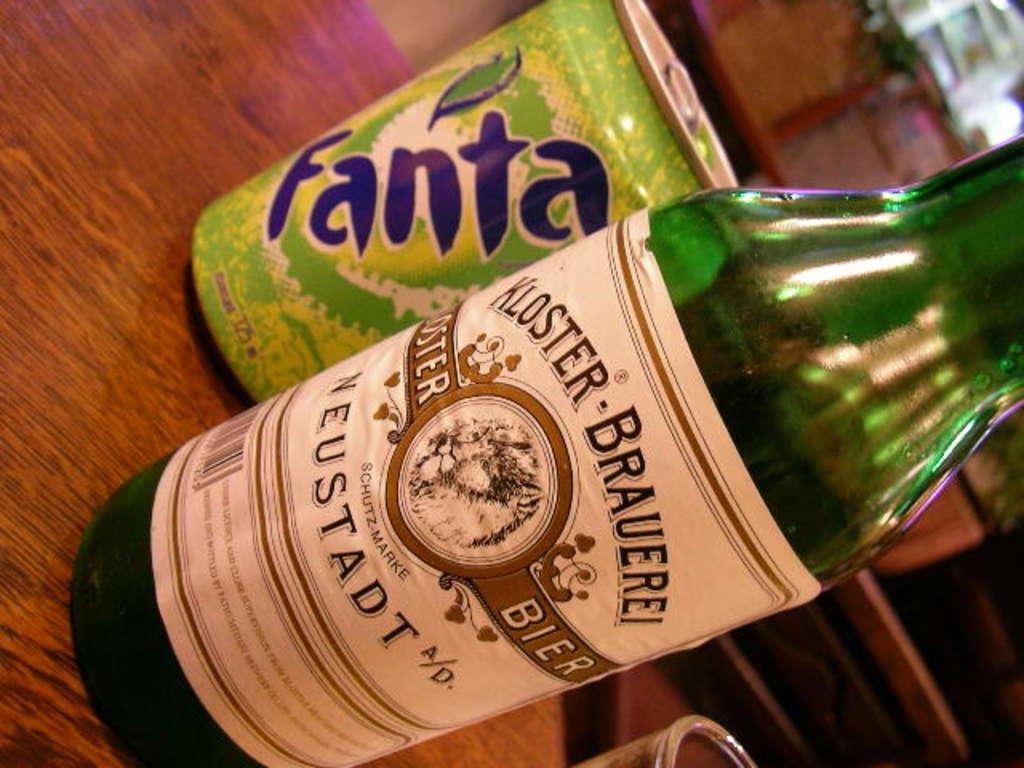What brand soda is behind the beer bottle?
Offer a terse response. Fanta. What brand of beer?
Your answer should be very brief. Kloster brauerei. 